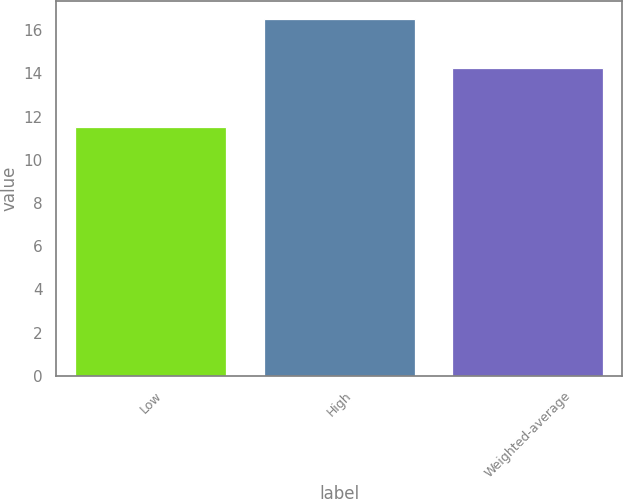Convert chart to OTSL. <chart><loc_0><loc_0><loc_500><loc_500><bar_chart><fcel>Low<fcel>High<fcel>Weighted-average<nl><fcel>11.5<fcel>16.5<fcel>14.23<nl></chart> 